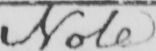Transcribe the text shown in this historical manuscript line. Note 